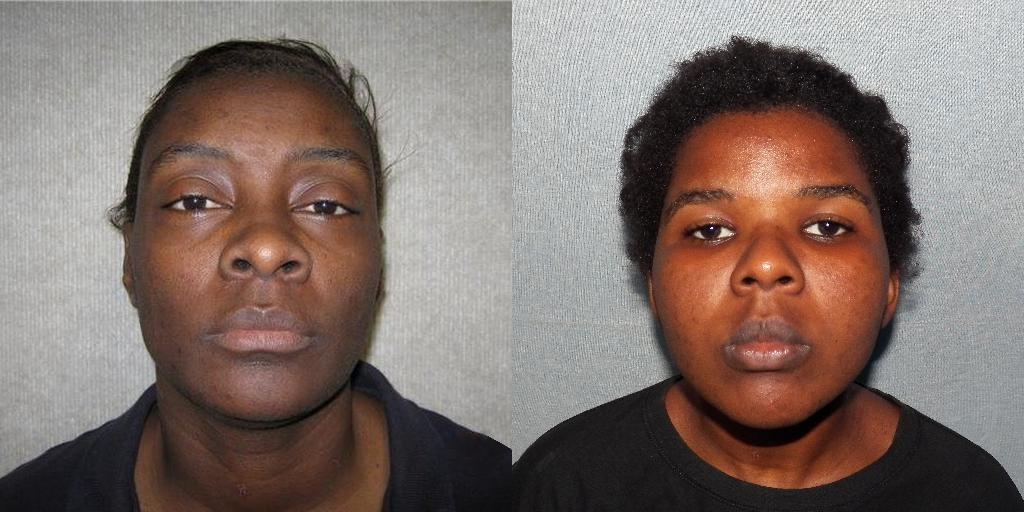Please provide a concise description of this image. This is a collage image. In these images we can see two persons. The background of the images is white. 